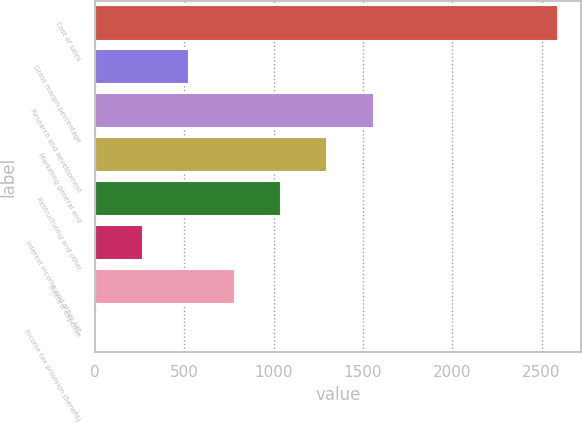Convert chart to OTSL. <chart><loc_0><loc_0><loc_500><loc_500><bar_chart><fcel>Cost of sales<fcel>Gross margin percentage<fcel>Research and development<fcel>Marketing general and<fcel>Restructuring and other<fcel>Interest income and other net<fcel>Interest expense<fcel>Income tax provision (benefit)<nl><fcel>2590<fcel>529.2<fcel>1559.6<fcel>1302<fcel>1044.4<fcel>271.6<fcel>786.8<fcel>14<nl></chart> 